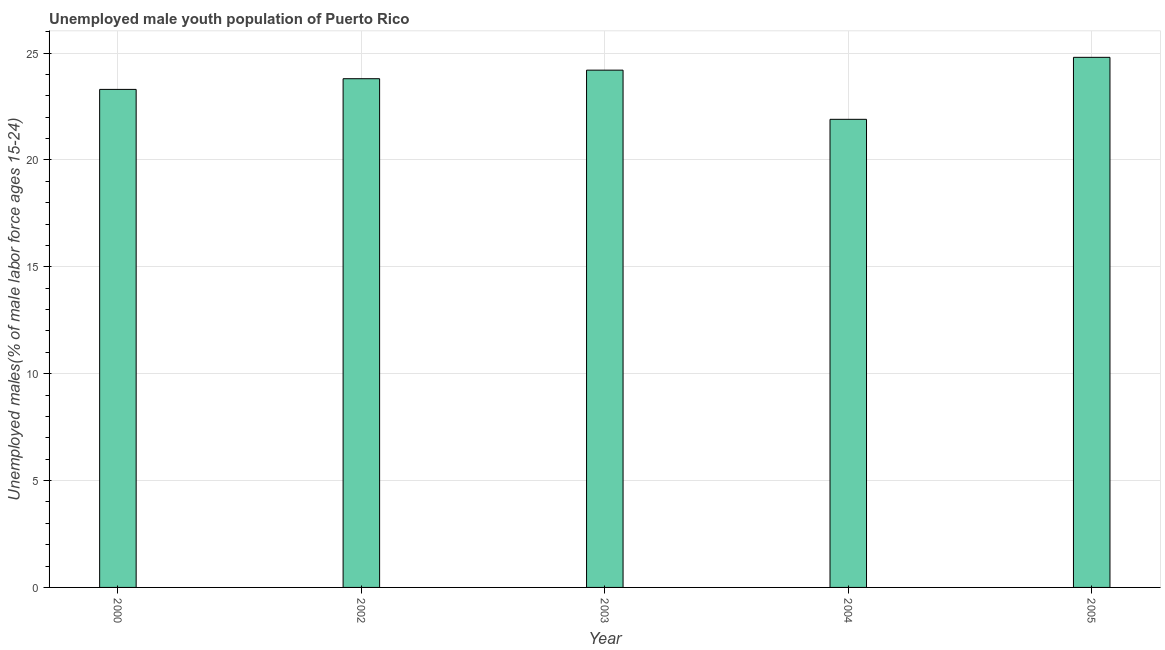Does the graph contain grids?
Your answer should be compact. Yes. What is the title of the graph?
Your answer should be very brief. Unemployed male youth population of Puerto Rico. What is the label or title of the X-axis?
Make the answer very short. Year. What is the label or title of the Y-axis?
Your response must be concise. Unemployed males(% of male labor force ages 15-24). What is the unemployed male youth in 2002?
Your answer should be compact. 23.8. Across all years, what is the maximum unemployed male youth?
Your answer should be compact. 24.8. Across all years, what is the minimum unemployed male youth?
Keep it short and to the point. 21.9. In which year was the unemployed male youth maximum?
Offer a very short reply. 2005. What is the sum of the unemployed male youth?
Provide a succinct answer. 118. What is the difference between the unemployed male youth in 2002 and 2004?
Your response must be concise. 1.9. What is the average unemployed male youth per year?
Make the answer very short. 23.6. What is the median unemployed male youth?
Your answer should be very brief. 23.8. What is the ratio of the unemployed male youth in 2002 to that in 2003?
Provide a succinct answer. 0.98. What is the difference between the highest and the second highest unemployed male youth?
Make the answer very short. 0.6. In how many years, is the unemployed male youth greater than the average unemployed male youth taken over all years?
Offer a very short reply. 3. How many years are there in the graph?
Make the answer very short. 5. What is the difference between two consecutive major ticks on the Y-axis?
Keep it short and to the point. 5. What is the Unemployed males(% of male labor force ages 15-24) of 2000?
Provide a short and direct response. 23.3. What is the Unemployed males(% of male labor force ages 15-24) in 2002?
Give a very brief answer. 23.8. What is the Unemployed males(% of male labor force ages 15-24) of 2003?
Your response must be concise. 24.2. What is the Unemployed males(% of male labor force ages 15-24) in 2004?
Offer a very short reply. 21.9. What is the Unemployed males(% of male labor force ages 15-24) of 2005?
Give a very brief answer. 24.8. What is the difference between the Unemployed males(% of male labor force ages 15-24) in 2000 and 2003?
Make the answer very short. -0.9. What is the difference between the Unemployed males(% of male labor force ages 15-24) in 2000 and 2004?
Your response must be concise. 1.4. What is the difference between the Unemployed males(% of male labor force ages 15-24) in 2002 and 2004?
Provide a short and direct response. 1.9. What is the difference between the Unemployed males(% of male labor force ages 15-24) in 2002 and 2005?
Give a very brief answer. -1. What is the difference between the Unemployed males(% of male labor force ages 15-24) in 2003 and 2005?
Ensure brevity in your answer.  -0.6. What is the ratio of the Unemployed males(% of male labor force ages 15-24) in 2000 to that in 2002?
Provide a succinct answer. 0.98. What is the ratio of the Unemployed males(% of male labor force ages 15-24) in 2000 to that in 2004?
Your response must be concise. 1.06. What is the ratio of the Unemployed males(% of male labor force ages 15-24) in 2000 to that in 2005?
Provide a short and direct response. 0.94. What is the ratio of the Unemployed males(% of male labor force ages 15-24) in 2002 to that in 2004?
Give a very brief answer. 1.09. What is the ratio of the Unemployed males(% of male labor force ages 15-24) in 2003 to that in 2004?
Your answer should be very brief. 1.1. What is the ratio of the Unemployed males(% of male labor force ages 15-24) in 2004 to that in 2005?
Offer a very short reply. 0.88. 